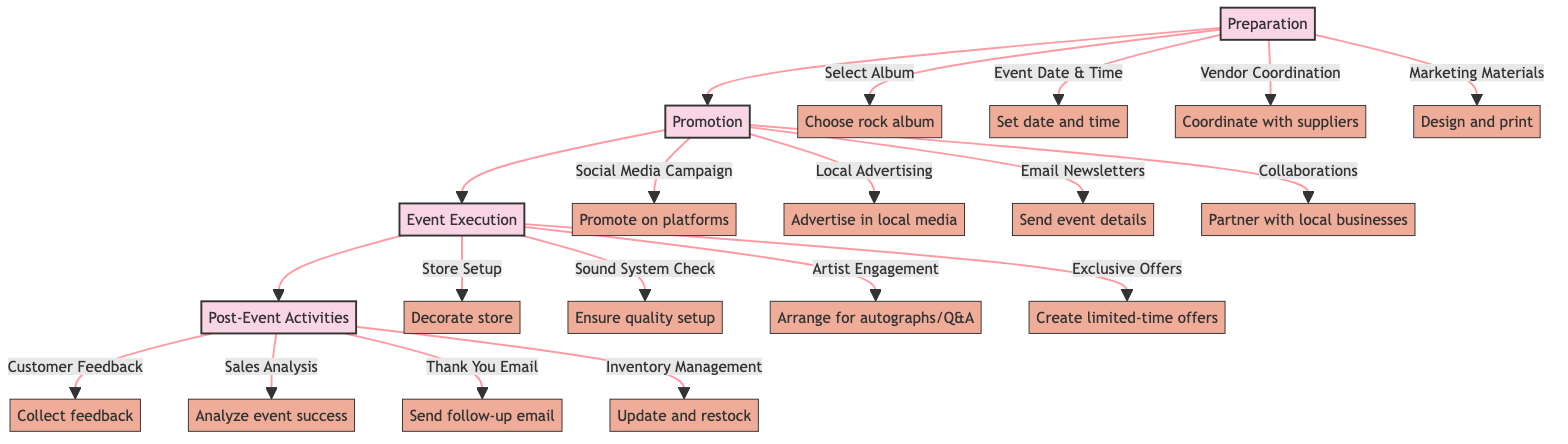What is the first stage in the pathway? The diagram starts with the first stage labeled as "Preparation". This is the initial stage where essential tasks are outlined before the event takes place.
Answer: Preparation How many elements are there in the Promotion stage? In the Promotion stage, there are four distinct elements listed. Each element contributes to the marketing and awareness of the event.
Answer: 4 What element involves coordinating with album suppliers? The element associated with coordinating with album suppliers is labeled "Vendor Coordination". This step is crucial for securing the albums needed for the event.
Answer: Vendor Coordination What activity occurs after the Event Execution stage? Following the Event Execution stage, the next activities are categorized under "Post-Event Activities". This stage includes tasks that happen after the event to evaluate its success and plan future actions.
Answer: Post-Event Activities Which element discusses promoting on social media? The element that addresses promoting on social media is called "Social Media Campaign". This outlines the strategies for using various platforms to attract customers.
Answer: Social Media Campaign How is the store set up for the event? The store setup involves decorating the store with related album artwork and merchandise. This creates an inviting atmosphere that resonates with the album being released.
Answer: Store Setup What do attendees receive after the event? After the event, attendees receive a "Thank You Email". This communication often includes appreciation for their attendance and information about future events.
Answer: Thank You Email What is the purpose of collecting customer feedback? The purpose of collecting customer feedback is to gather insights about attendees' experiences during the event. This information is vital for making improvements in future events.
Answer: Customer Feedback What is the last element in the Post-Event Activities stage? The last element in the Post-Event Activities stage is "Inventory Management". This step is crucial for assessing and updating stock based on the sales from the event.
Answer: Inventory Management 